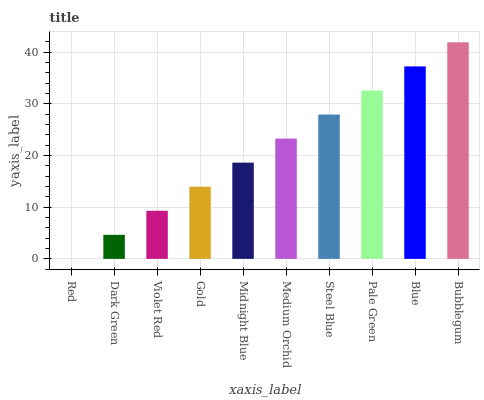Is Dark Green the minimum?
Answer yes or no. No. Is Dark Green the maximum?
Answer yes or no. No. Is Dark Green greater than Red?
Answer yes or no. Yes. Is Red less than Dark Green?
Answer yes or no. Yes. Is Red greater than Dark Green?
Answer yes or no. No. Is Dark Green less than Red?
Answer yes or no. No. Is Medium Orchid the high median?
Answer yes or no. Yes. Is Midnight Blue the low median?
Answer yes or no. Yes. Is Blue the high median?
Answer yes or no. No. Is Red the low median?
Answer yes or no. No. 